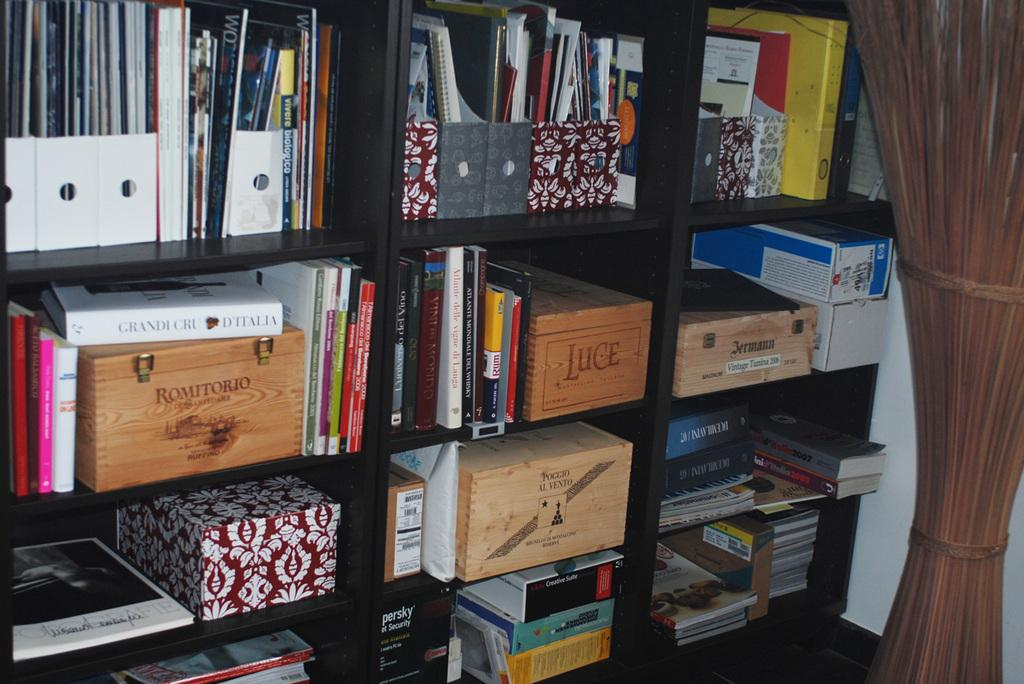What can be seen on the shelf in the image? There are books and boxes on the shelf in the image. What type of items are stored on the shelf? Books and boxes are stored on the shelf. Can you describe the object on the right side of the image? The object on the right side of the image is brown in color. Where is the nail located in the image? There is no nail present in the image. What type of food is being served in the lunchroom in the image? There is no lunchroom present in the image. 